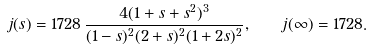<formula> <loc_0><loc_0><loc_500><loc_500>j ( s ) = 1 7 2 8 \, \frac { 4 ( 1 + s + s ^ { 2 } ) ^ { 3 } } { ( 1 - s ) ^ { 2 } ( 2 + s ) ^ { 2 } ( 1 + 2 s ) ^ { 2 } } , \quad j ( \infty ) = 1 7 2 8 .</formula> 